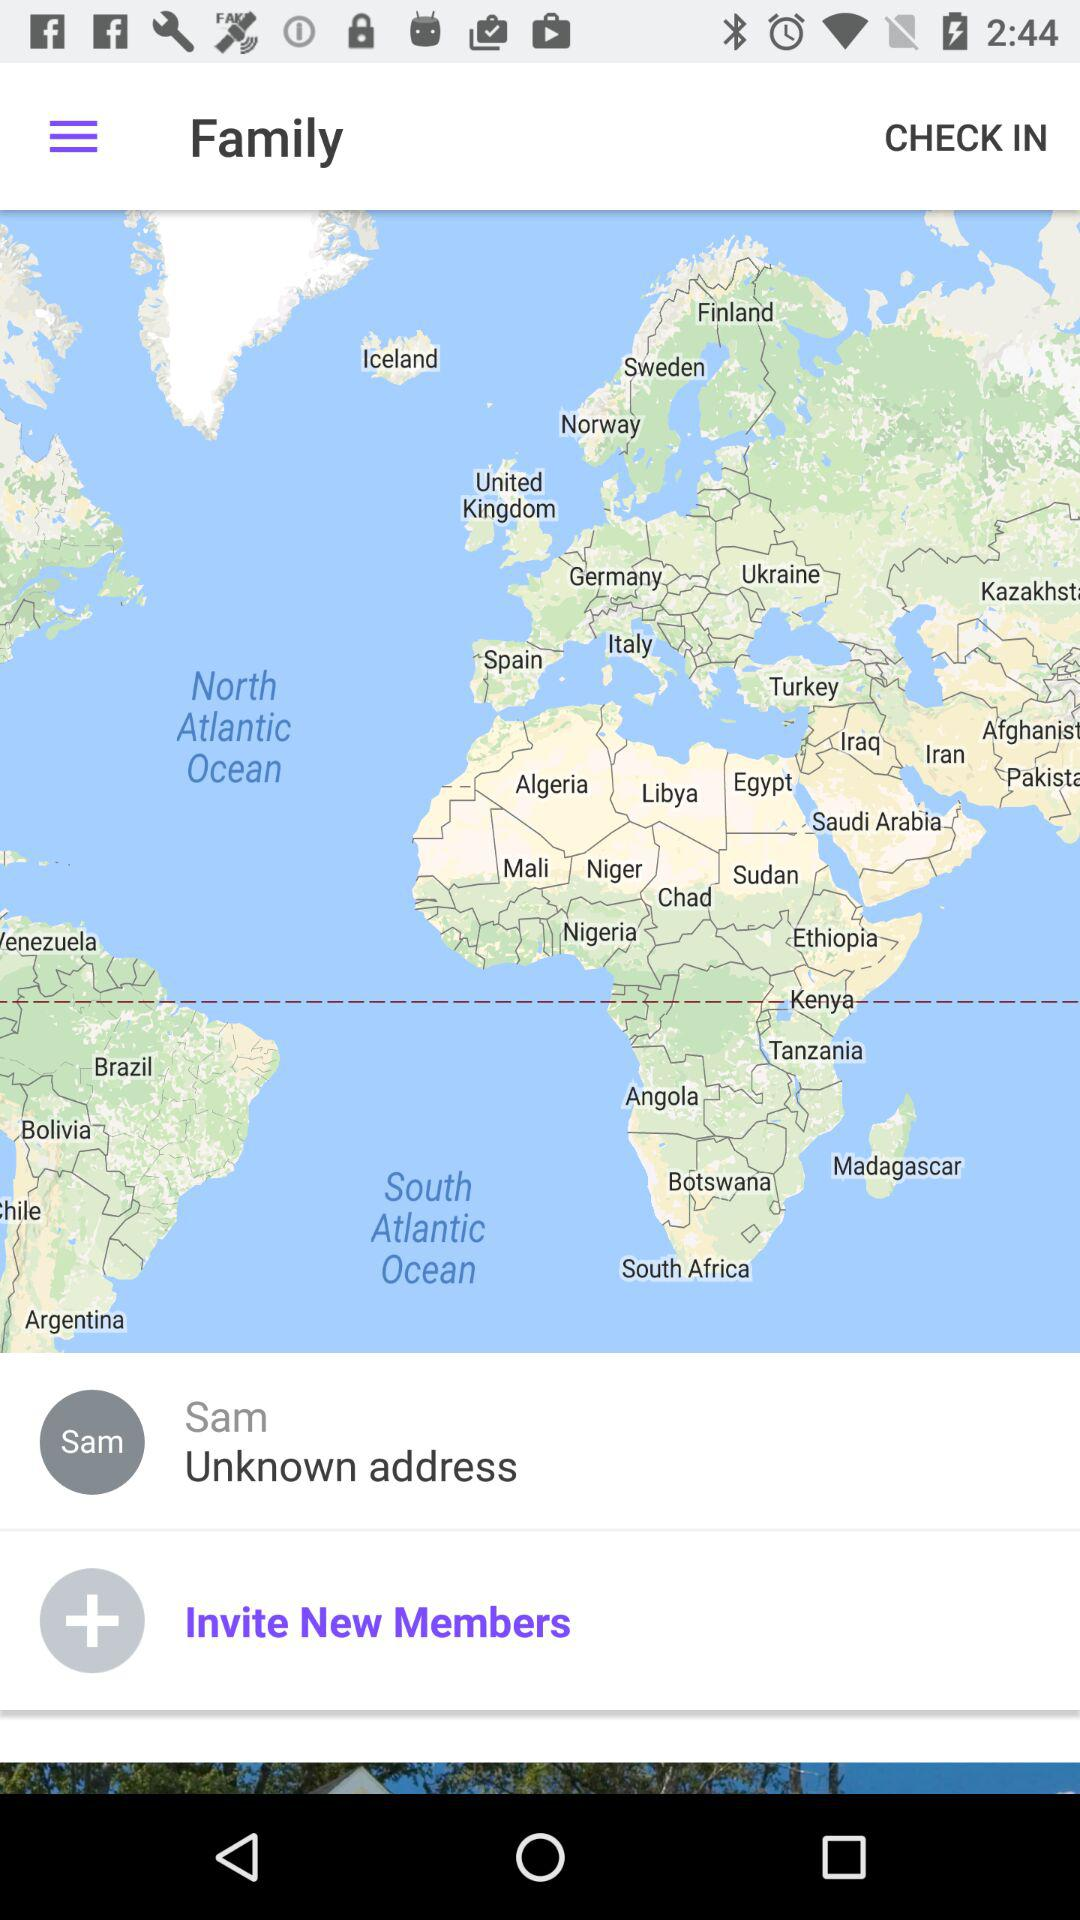What's the address of Sam? The address of Sam is "Unknown". 